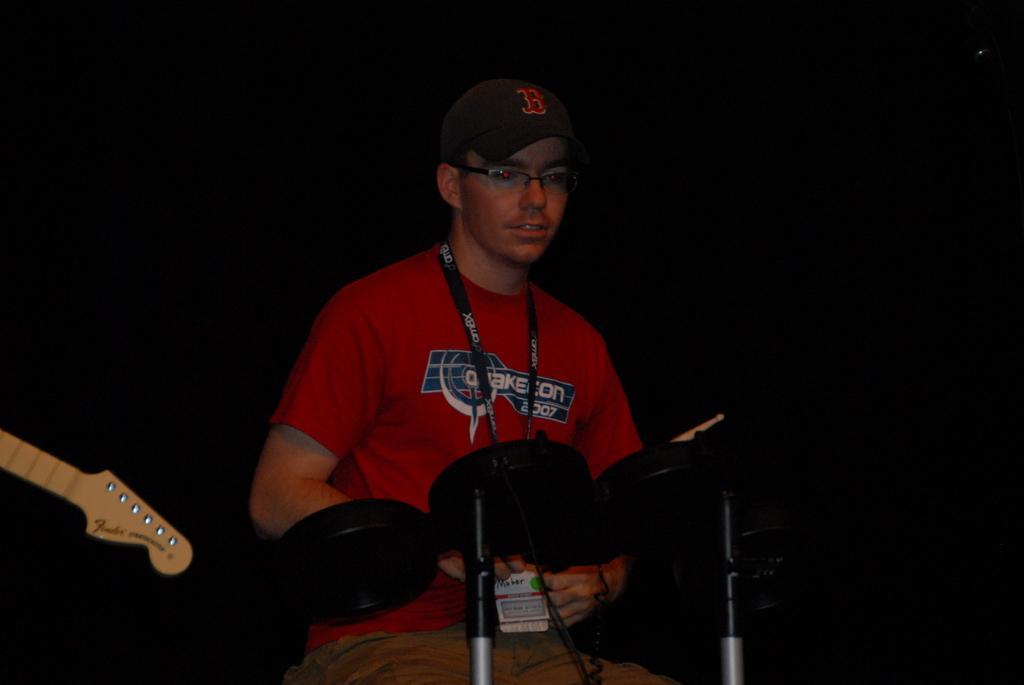How would you summarize this image in a sentence or two? In this image wearing red t-shirt and cap is playing one musical instrument. The background is dark. 